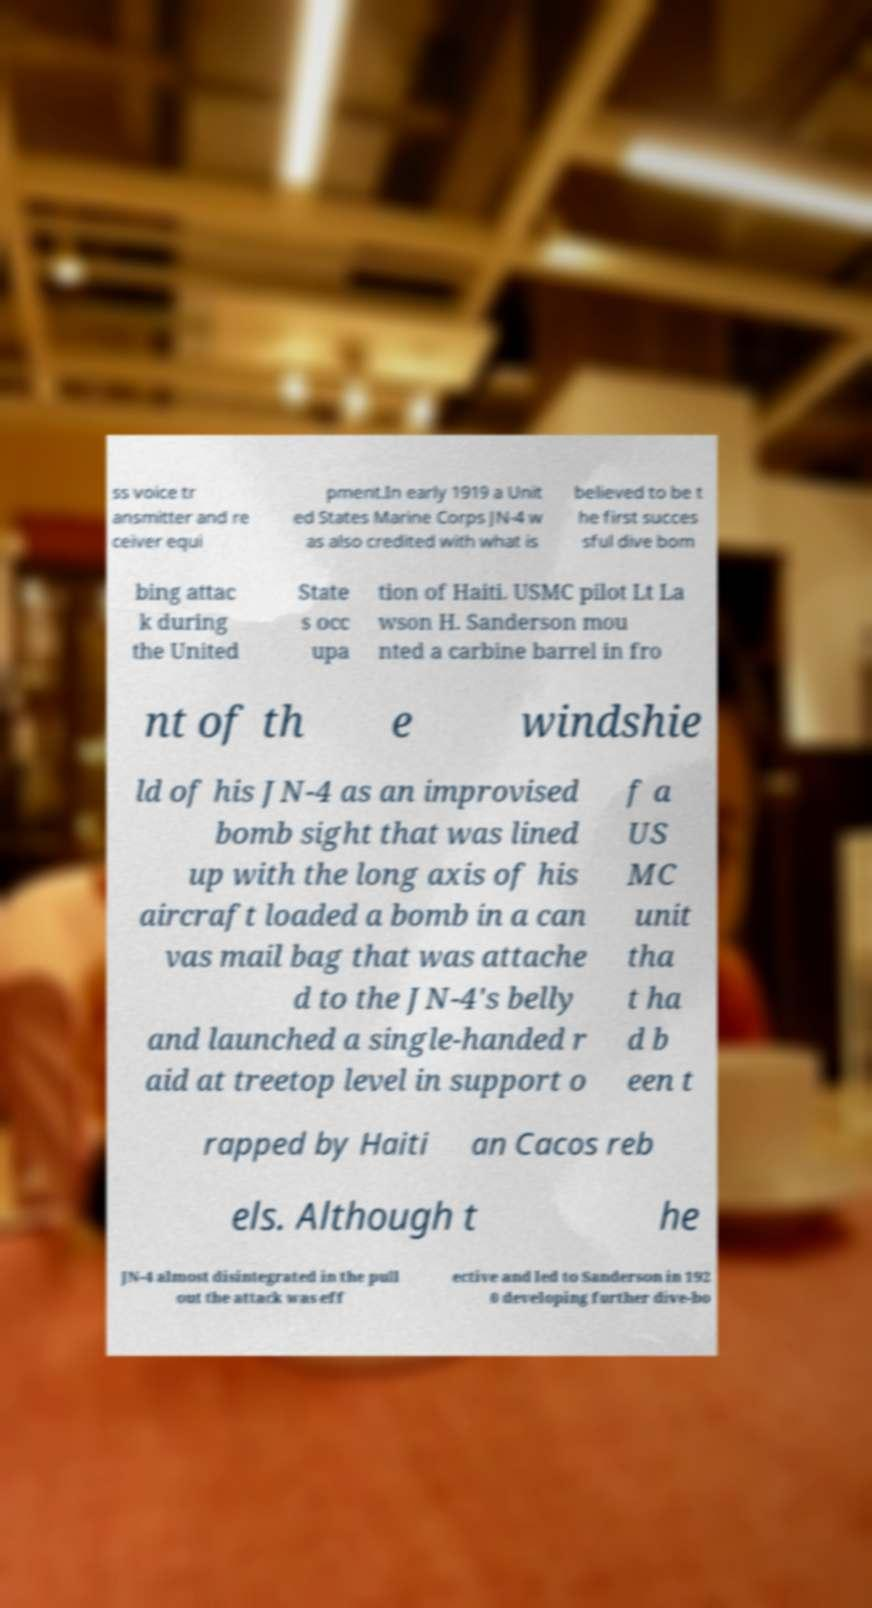I need the written content from this picture converted into text. Can you do that? ss voice tr ansmitter and re ceiver equi pment.In early 1919 a Unit ed States Marine Corps JN-4 w as also credited with what is believed to be t he first succes sful dive bom bing attac k during the United State s occ upa tion of Haiti. USMC pilot Lt La wson H. Sanderson mou nted a carbine barrel in fro nt of th e windshie ld of his JN-4 as an improvised bomb sight that was lined up with the long axis of his aircraft loaded a bomb in a can vas mail bag that was attache d to the JN-4's belly and launched a single-handed r aid at treetop level in support o f a US MC unit tha t ha d b een t rapped by Haiti an Cacos reb els. Although t he JN-4 almost disintegrated in the pull out the attack was eff ective and led to Sanderson in 192 0 developing further dive-bo 